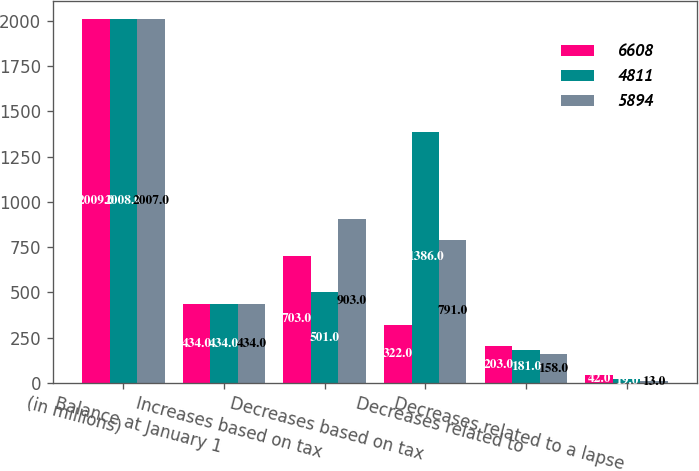Convert chart to OTSL. <chart><loc_0><loc_0><loc_500><loc_500><stacked_bar_chart><ecel><fcel>(in millions)<fcel>Balance at January 1<fcel>Increases based on tax<fcel>Decreases based on tax<fcel>Decreases related to<fcel>Decreases related to a lapse<nl><fcel>6608<fcel>2009<fcel>434<fcel>703<fcel>322<fcel>203<fcel>42<nl><fcel>4811<fcel>2008<fcel>434<fcel>501<fcel>1386<fcel>181<fcel>19<nl><fcel>5894<fcel>2007<fcel>434<fcel>903<fcel>791<fcel>158<fcel>13<nl></chart> 